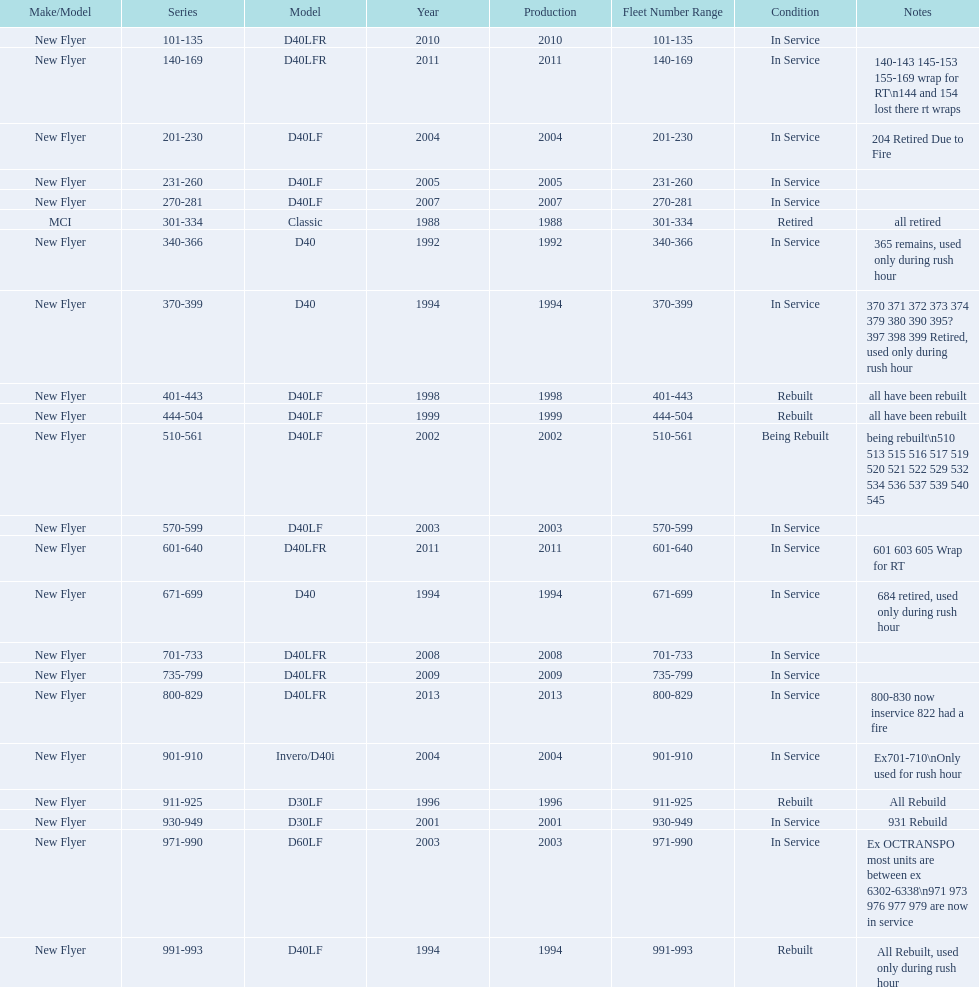What are all the series of buses? 101-135, 140-169, 201-230, 231-260, 270-281, 301-334, 340-366, 370-399, 401-443, 444-504, 510-561, 570-599, 601-640, 671-699, 701-733, 735-799, 800-829, 901-910, 911-925, 930-949, 971-990, 991-993. Which are the newest? 800-829. 